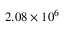<formula> <loc_0><loc_0><loc_500><loc_500>2 . 0 8 \times 1 0 ^ { 6 }</formula> 